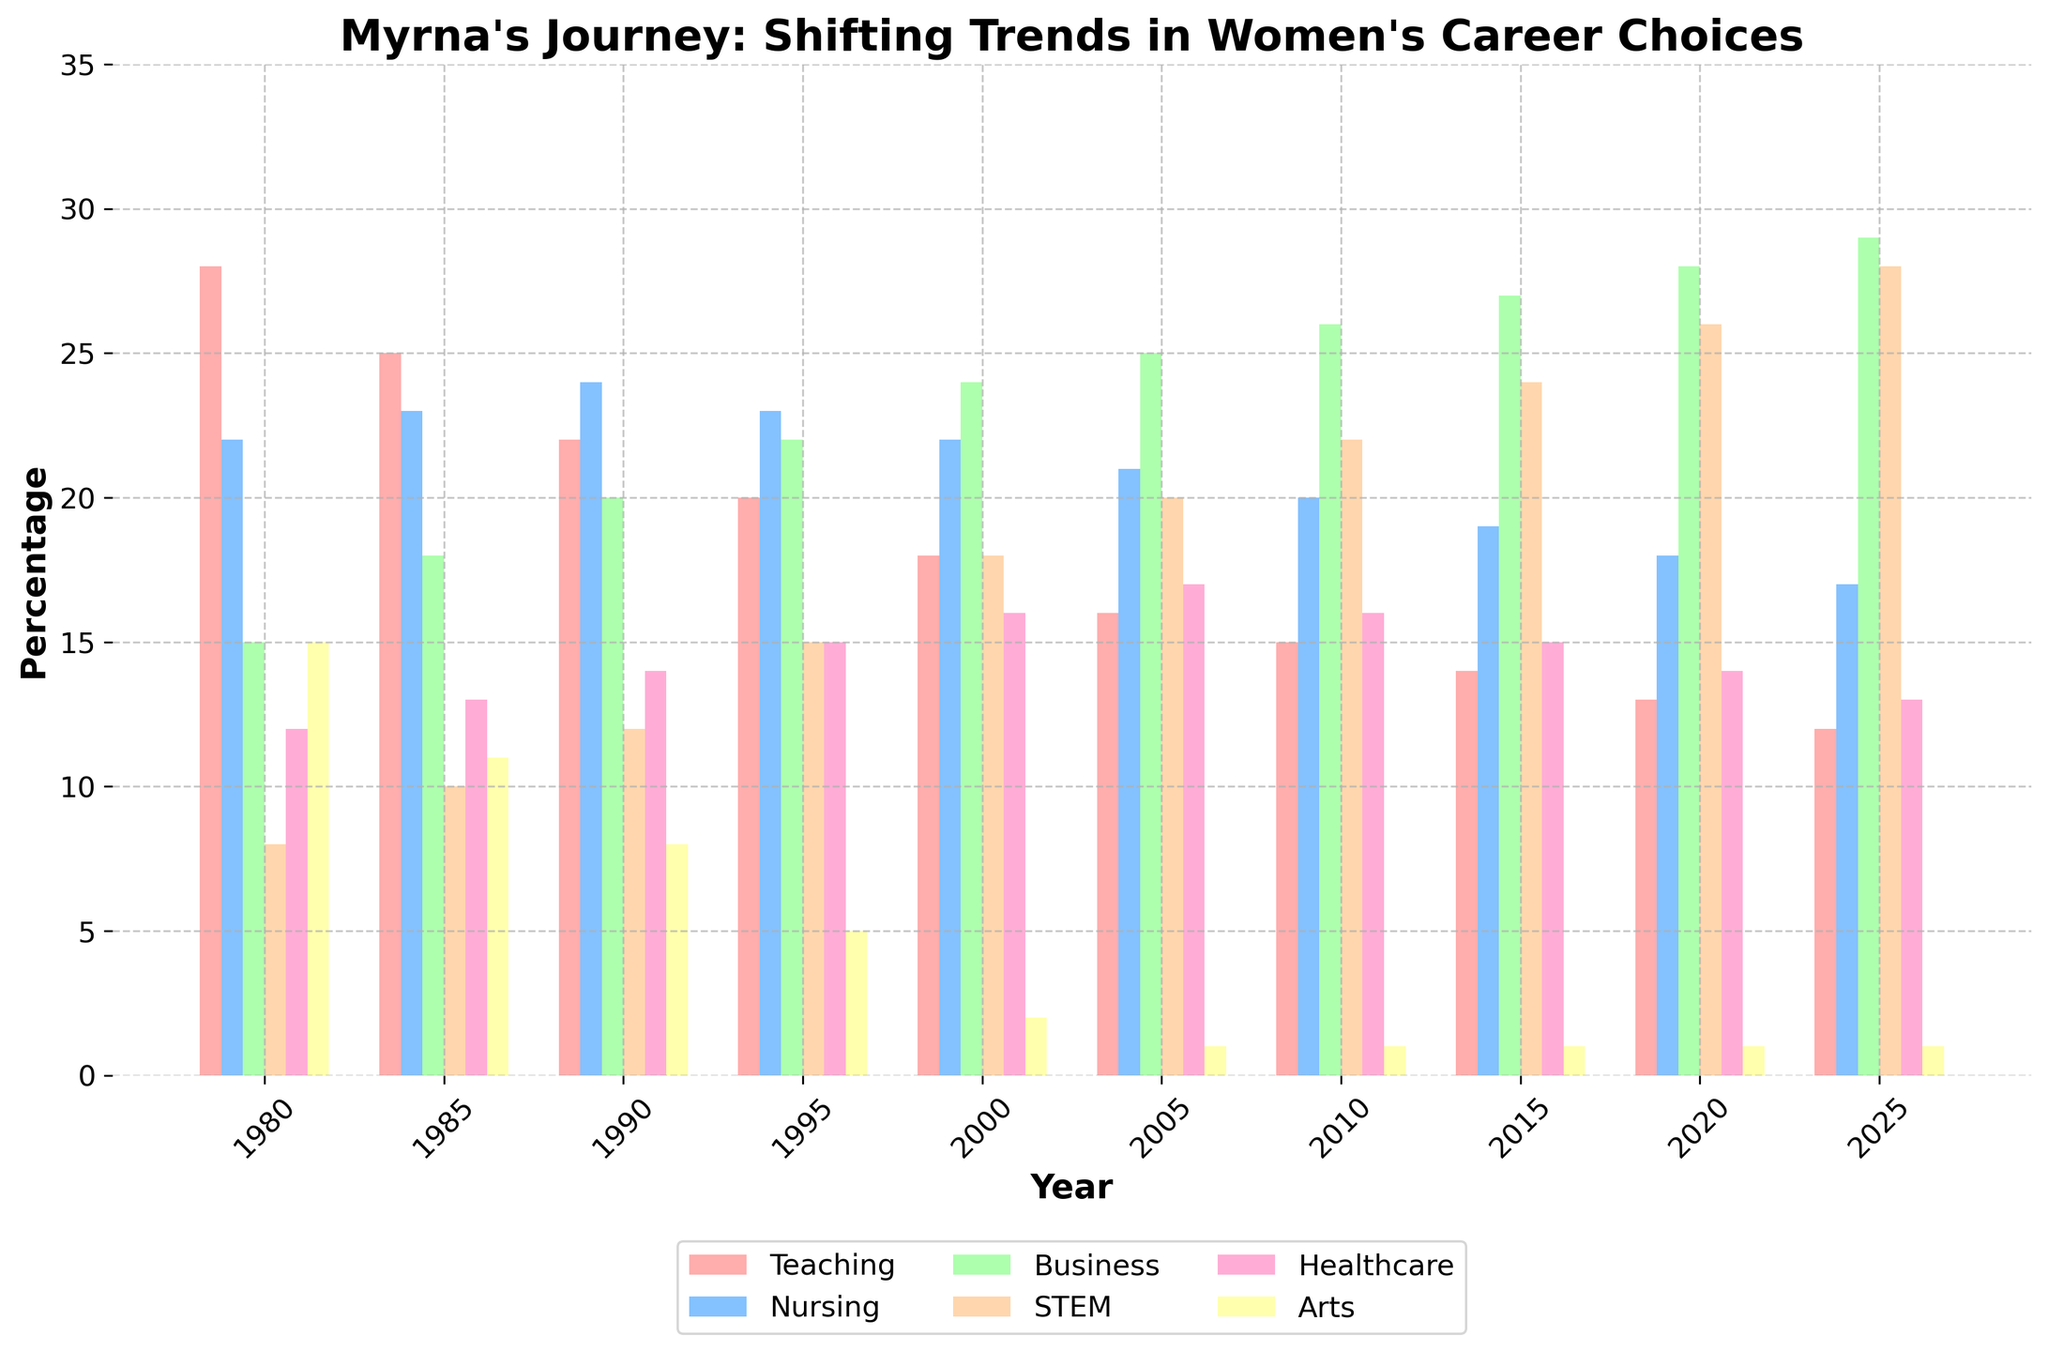What career choice saw the biggest relative increase from 1980 to 2025? To determine the biggest relative increase, we calculate the percentage increase for each career. Teaching: (12-28)/28 = -57.14%, Nursing: (17-22)/22 = -22.73%, Business: (29-15)/15 = 93.33%, STEM: (28-8)/8 = 250%, Healthcare: (13-12)/12 = 8.33%, Arts: (1-15)/15 = -93.33%. STEM has the largest percentage increase.
Answer: STEM Which career choice had the highest percentage in 1980? By looking at the data for 1980, we compare the percentages: Teaching (28), Nursing (22), Business (15), STEM (8), Healthcare (12), Arts (15). Teaching has the highest percentage.
Answer: Teaching What is the combined percentage for Business and STEM in 2025? The values for 2025 are Business (29) and STEM (28). Adding them gives 29 + 28 = 57%.
Answer: 57% Did the percentage of women choosing Arts decrease more than the percentage choosing Teaching from 1980 to 2025? Teaching went from 28% to 12%, a change of -16%. Arts went from 15% to 1%, a change of -14%. Teaching's decrease is -16% and Art's decrease is -14%; therefore, Teaching decreased more than Arts.
Answer: No Which career choices have consistently increased from 1980 to 2025? By observing the chart and the data, we can see that both Business (15 to 29) and STEM (8 to 28) have consistently increased from 1980 to 2025.
Answer: Business, STEM In 1995, which career had a higher percentage: Nursing or Business? Referring to the 1995 data, Nursing is at 23% and Business is at 22%. Nursing is higher than Business.
Answer: Nursing What is the average percentage for Nursing from 2000 to 2025? Averaging the Nursing values in the years 2000 (22), 2005 (21), 2010 (20), 2015 (19), 2020 (18), 2025 (17): (22+21+20+19+18+17)/6 = 19.5%.
Answer: 19.5% Which year had the highest combined percentage for Healthcare and STEM? Adding their values for each year: 1980 (12+8=20), 1985 (13+10=23), 1990 (14+12=26), 1995 (15+15=30), 2000 (16+18=34), 2005 (17+20=37), 2010 (16+22=38), 2015 (15+24=39), 2020 (14+26=40), 2025 (13+28=41). The year with the highest combined percentage is 2025, with 41%.
Answer: 2025 